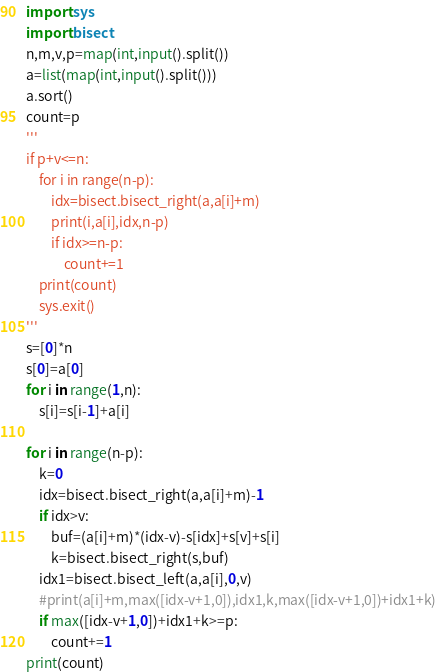<code> <loc_0><loc_0><loc_500><loc_500><_Python_>import sys
import bisect
n,m,v,p=map(int,input().split())
a=list(map(int,input().split()))
a.sort()
count=p
'''
if p+v<=n:
    for i in range(n-p):
        idx=bisect.bisect_right(a,a[i]+m)
        print(i,a[i],idx,n-p)
        if idx>=n-p:
            count+=1
    print(count)
    sys.exit()
'''
s=[0]*n
s[0]=a[0]
for i in range(1,n):
    s[i]=s[i-1]+a[i]

for i in range(n-p):
    k=0
    idx=bisect.bisect_right(a,a[i]+m)-1
    if idx>v:
        buf=(a[i]+m)*(idx-v)-s[idx]+s[v]+s[i]
        k=bisect.bisect_right(s,buf)
    idx1=bisect.bisect_left(a,a[i],0,v)
    #print(a[i]+m,max([idx-v+1,0]),idx1,k,max([idx-v+1,0])+idx1+k)
    if max([idx-v+1,0])+idx1+k>=p:
        count+=1
print(count)</code> 